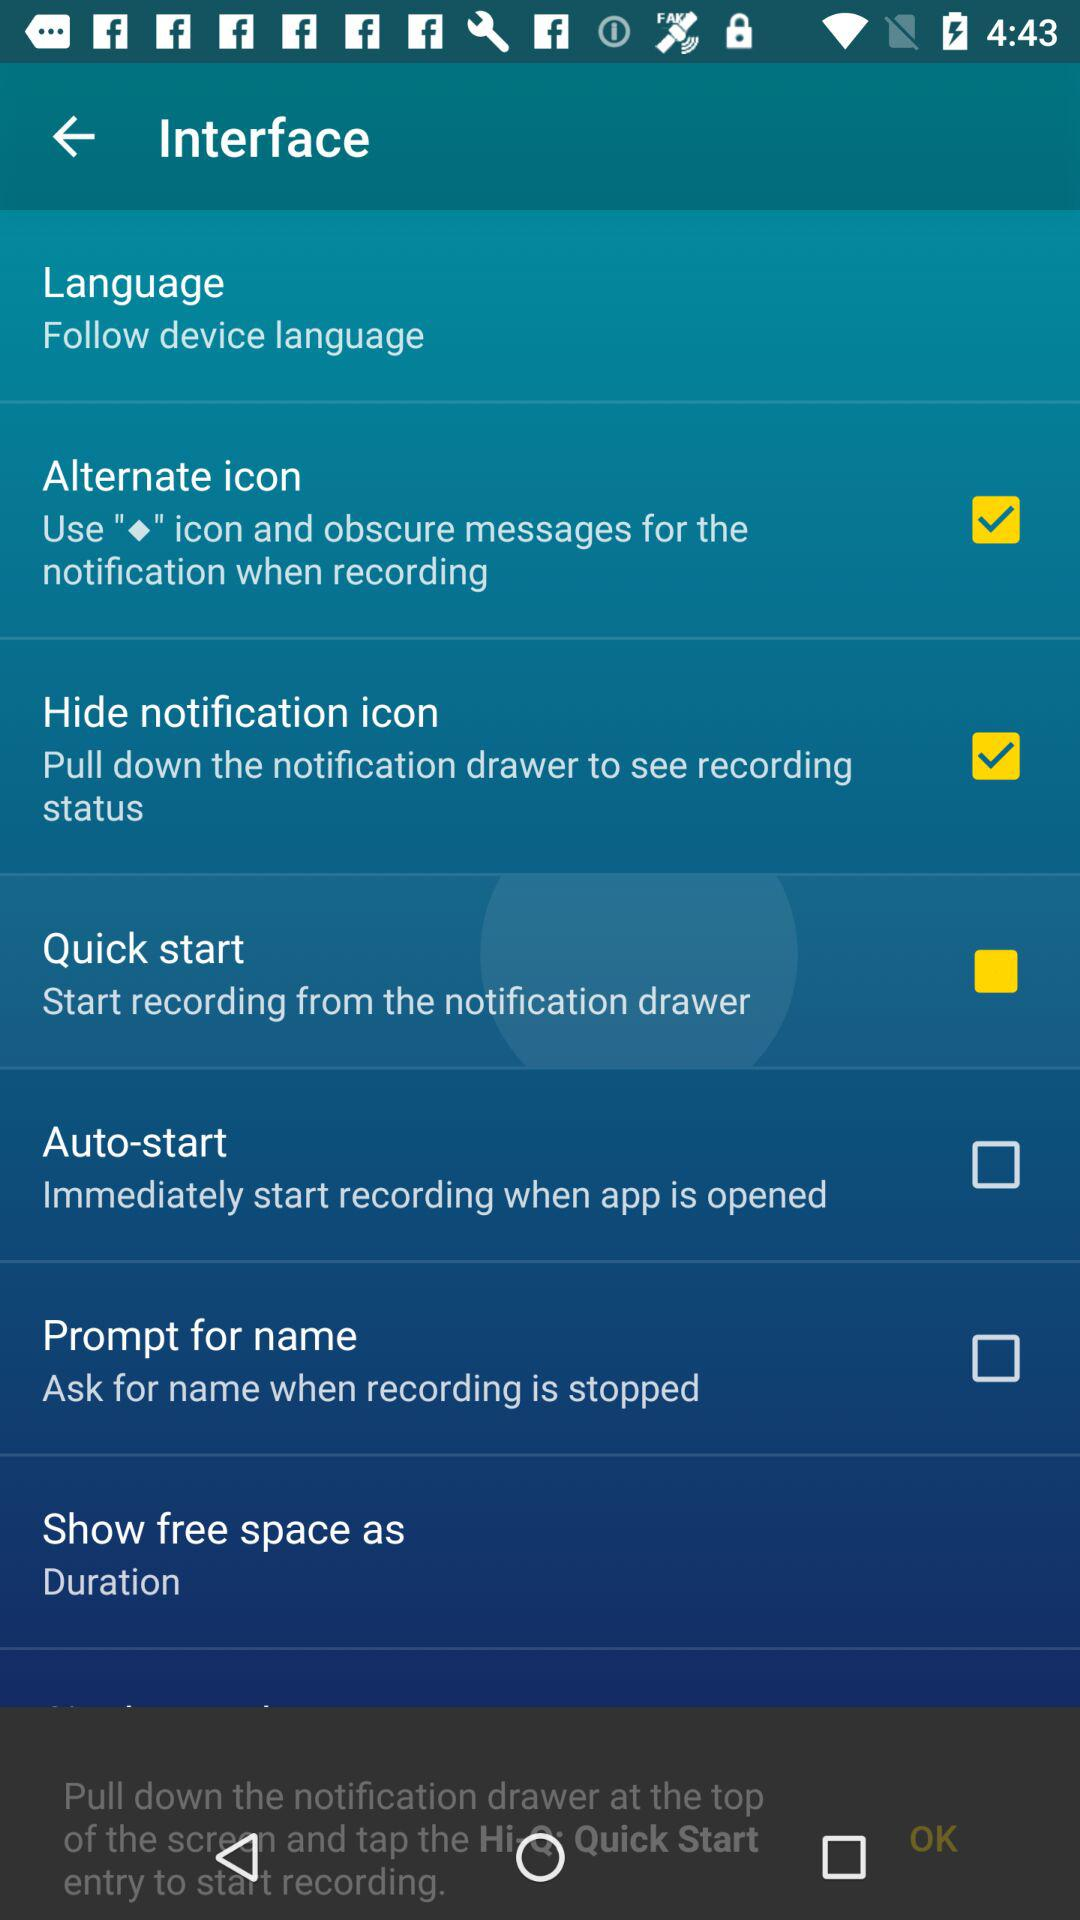What is the status of the "Alternate icon"? The status of the "Alternate icon" is "on". 